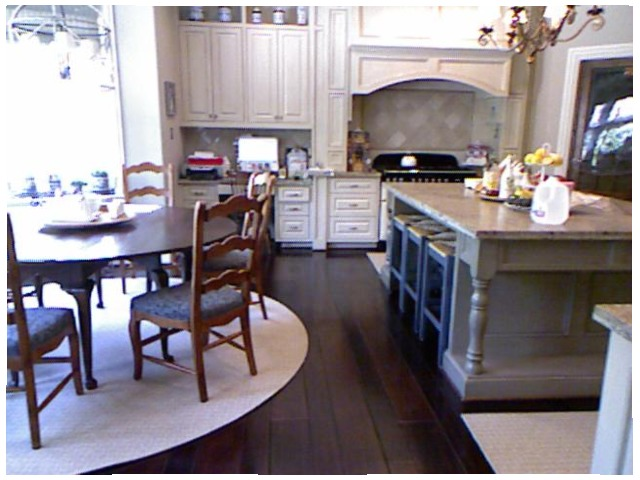<image>
Can you confirm if the table is in front of the chair? Yes. The table is positioned in front of the chair, appearing closer to the camera viewpoint. Where is the chair in relation to the table? Is it on the table? No. The chair is not positioned on the table. They may be near each other, but the chair is not supported by or resting on top of the table. Where is the chair in relation to the table? Is it to the left of the table? Yes. From this viewpoint, the chair is positioned to the left side relative to the table. 